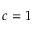Convert formula to latex. <formula><loc_0><loc_0><loc_500><loc_500>c = 1</formula> 